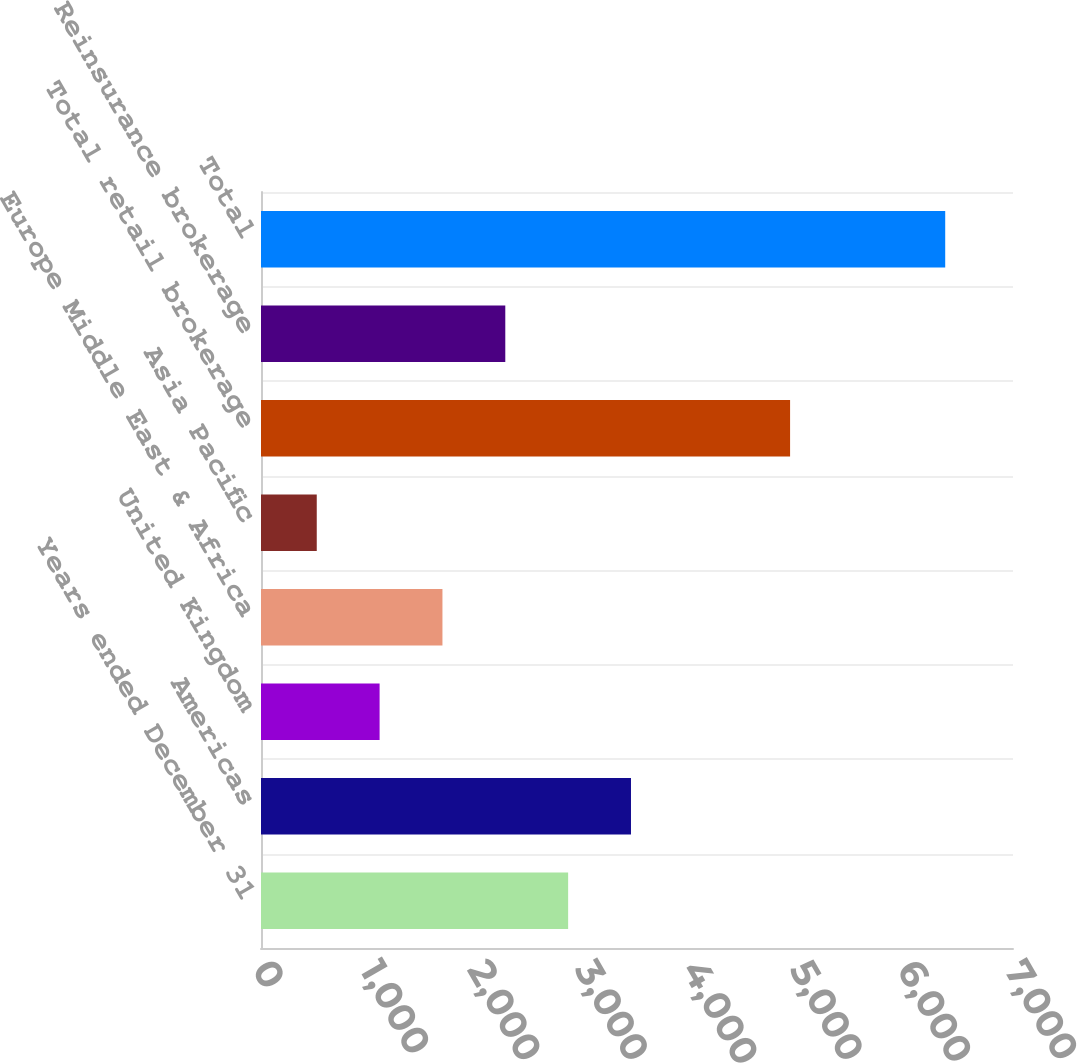<chart> <loc_0><loc_0><loc_500><loc_500><bar_chart><fcel>Years ended December 31<fcel>Americas<fcel>United Kingdom<fcel>Europe Middle East & Africa<fcel>Asia Pacific<fcel>Total retail brokerage<fcel>Reinsurance brokerage<fcel>Total<nl><fcel>2859<fcel>3444<fcel>1104<fcel>1689<fcel>519<fcel>4925<fcel>2274<fcel>6369<nl></chart> 